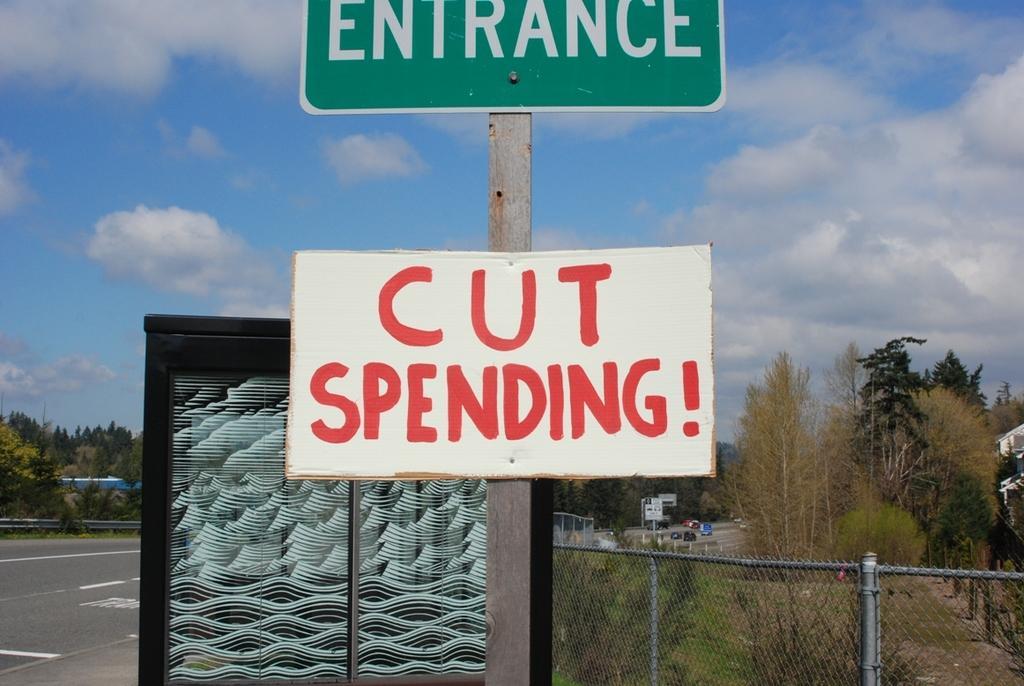Could you give a brief overview of what you see in this image? The picture is taken outside a city, on the road. In the foreground of the picture there are boards, pole, road and fencing. On the right side there are trees. On the left side there are trees and road. In the center of the background there are vehicles and trees. Sky is sunny and little bit cloudy. 